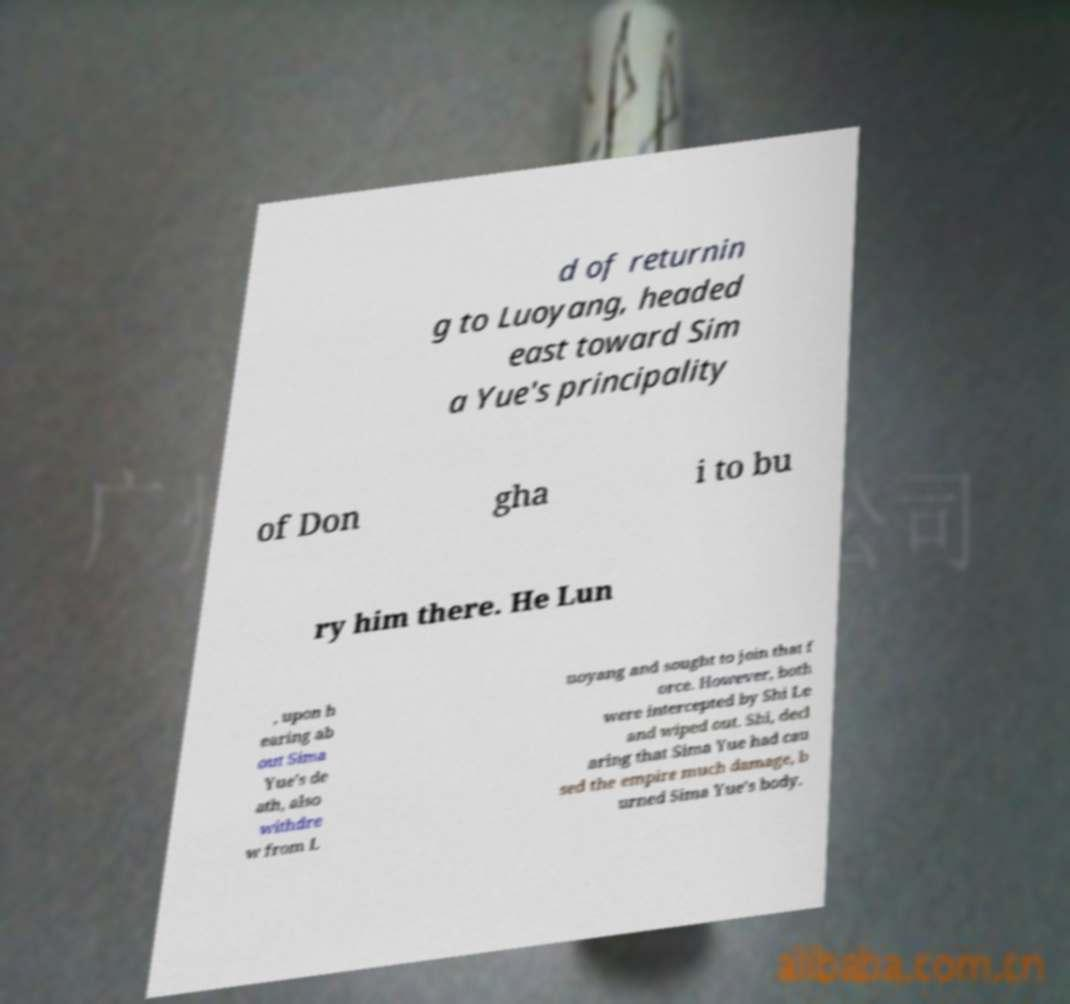Can you read and provide the text displayed in the image?This photo seems to have some interesting text. Can you extract and type it out for me? d of returnin g to Luoyang, headed east toward Sim a Yue's principality of Don gha i to bu ry him there. He Lun , upon h earing ab out Sima Yue's de ath, also withdre w from L uoyang and sought to join that f orce. However, both were intercepted by Shi Le and wiped out. Shi, decl aring that Sima Yue had cau sed the empire much damage, b urned Sima Yue's body. 